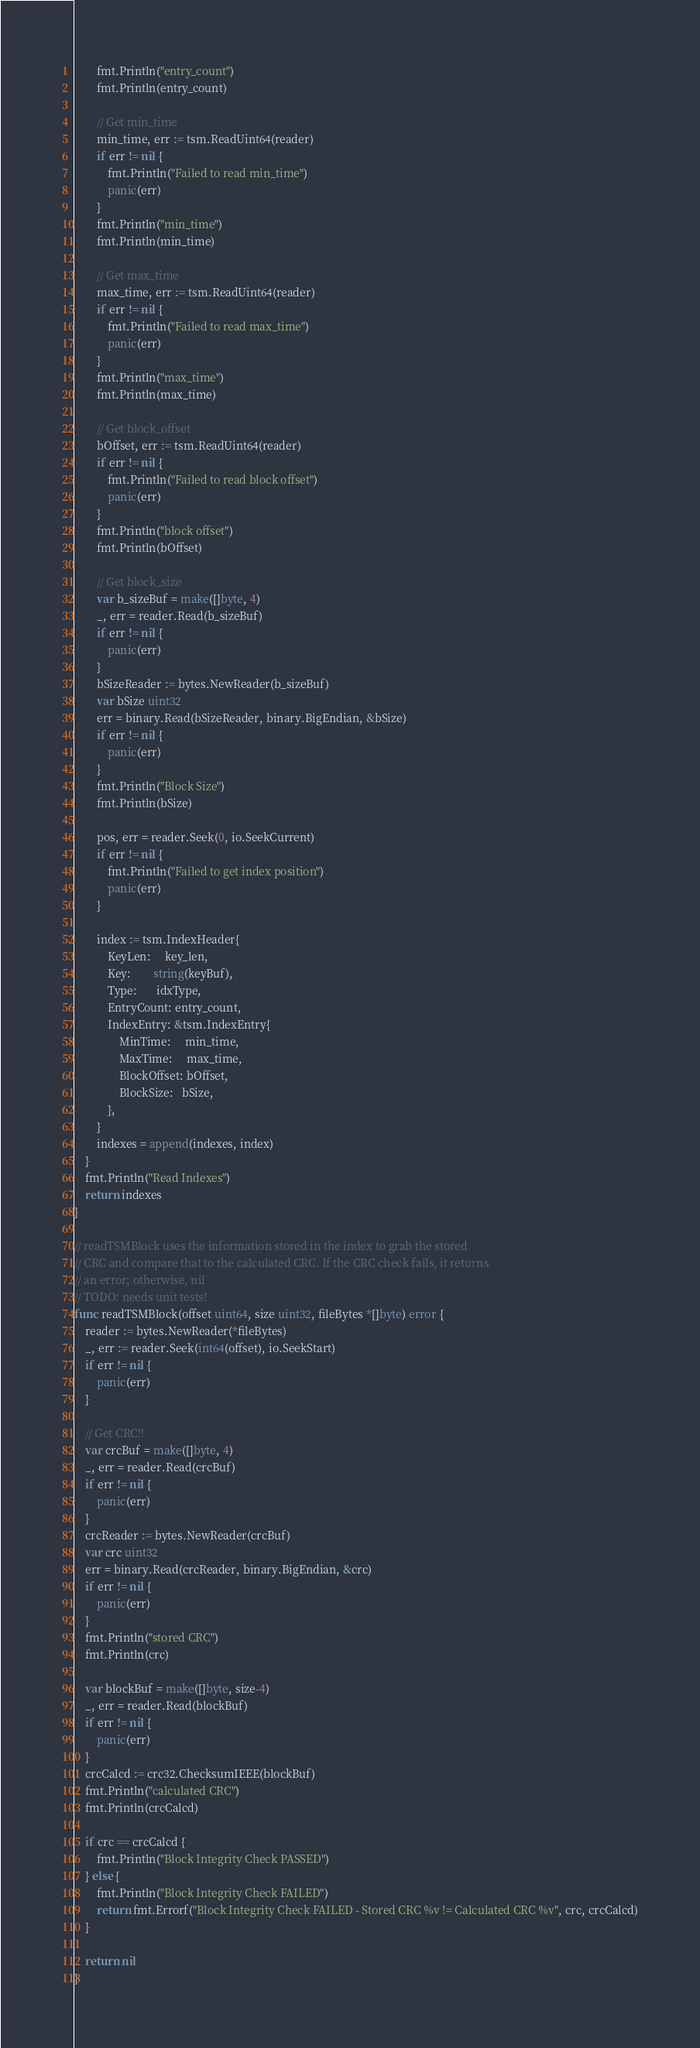<code> <loc_0><loc_0><loc_500><loc_500><_Go_>		fmt.Println("entry_count")
		fmt.Println(entry_count)

		// Get min_time
		min_time, err := tsm.ReadUint64(reader)
		if err != nil {
			fmt.Println("Failed to read min_time")
			panic(err)
		}
		fmt.Println("min_time")
		fmt.Println(min_time)

		// Get max_time
		max_time, err := tsm.ReadUint64(reader)
		if err != nil {
			fmt.Println("Failed to read max_time")
			panic(err)
		}
		fmt.Println("max_time")
		fmt.Println(max_time)

		// Get block_offset
		bOffset, err := tsm.ReadUint64(reader)
		if err != nil {
			fmt.Println("Failed to read block offset")
			panic(err)
		}
		fmt.Println("block offset")
		fmt.Println(bOffset)

		// Get block_size
		var b_sizeBuf = make([]byte, 4)
		_, err = reader.Read(b_sizeBuf)
		if err != nil {
			panic(err)
		}
		bSizeReader := bytes.NewReader(b_sizeBuf)
		var bSize uint32
		err = binary.Read(bSizeReader, binary.BigEndian, &bSize)
		if err != nil {
			panic(err)
		}
		fmt.Println("Block Size")
		fmt.Println(bSize)

		pos, err = reader.Seek(0, io.SeekCurrent)
		if err != nil {
			fmt.Println("Failed to get index position")
			panic(err)
		}

		index := tsm.IndexHeader{
			KeyLen:     key_len,
			Key:        string(keyBuf),
			Type:       idxType,
			EntryCount: entry_count,
			IndexEntry: &tsm.IndexEntry{
				MinTime:     min_time,
				MaxTime:     max_time,
				BlockOffset: bOffset,
				BlockSize:   bSize,
			},
		}
		indexes = append(indexes, index)
	}
	fmt.Println("Read Indexes")
	return indexes
}

// readTSMBlock uses the information stored in the index to grab the stored
// CRC and compare that to the calculated CRC. If the CRC check fails, it returns
// an error; otherwise, nil
// TODO: needs unit tests!
func readTSMBlock(offset uint64, size uint32, fileBytes *[]byte) error {
	reader := bytes.NewReader(*fileBytes)
	_, err := reader.Seek(int64(offset), io.SeekStart)
	if err != nil {
		panic(err)
	}

	// Get CRC!!
	var crcBuf = make([]byte, 4)
	_, err = reader.Read(crcBuf)
	if err != nil {
		panic(err)
	}
	crcReader := bytes.NewReader(crcBuf)
	var crc uint32
	err = binary.Read(crcReader, binary.BigEndian, &crc)
	if err != nil {
		panic(err)
	}
	fmt.Println("stored CRC")
	fmt.Println(crc)

	var blockBuf = make([]byte, size-4)
	_, err = reader.Read(blockBuf)
	if err != nil {
		panic(err)
	}
	crcCalcd := crc32.ChecksumIEEE(blockBuf)
	fmt.Println("calculated CRC")
	fmt.Println(crcCalcd)

	if crc == crcCalcd {
		fmt.Println("Block Integrity Check PASSED")
	} else {
		fmt.Println("Block Integrity Check FAILED")
		return fmt.Errorf("Block Integrity Check FAILED - Stored CRC %v != Calculated CRC %v", crc, crcCalcd)
	}

	return nil
}
</code> 